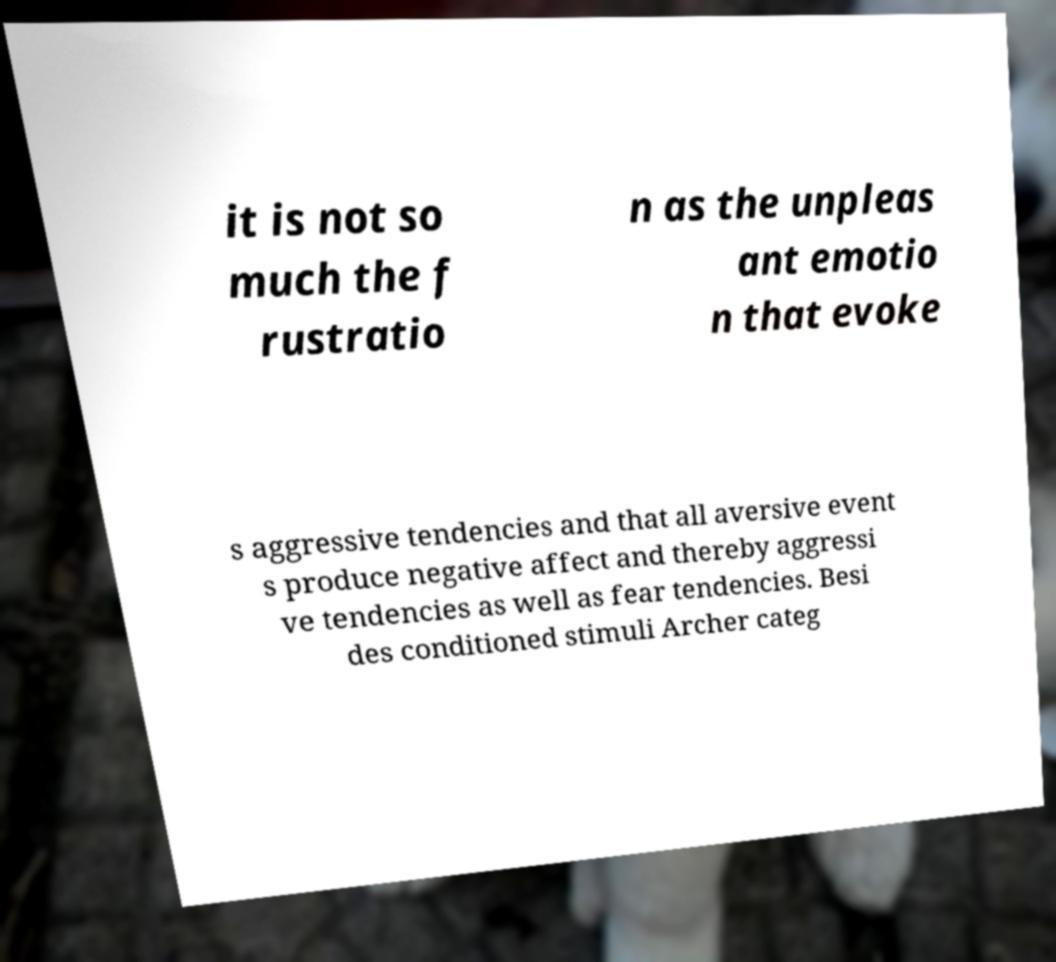Could you assist in decoding the text presented in this image and type it out clearly? it is not so much the f rustratio n as the unpleas ant emotio n that evoke s aggressive tendencies and that all aversive event s produce negative affect and thereby aggressi ve tendencies as well as fear tendencies. Besi des conditioned stimuli Archer categ 